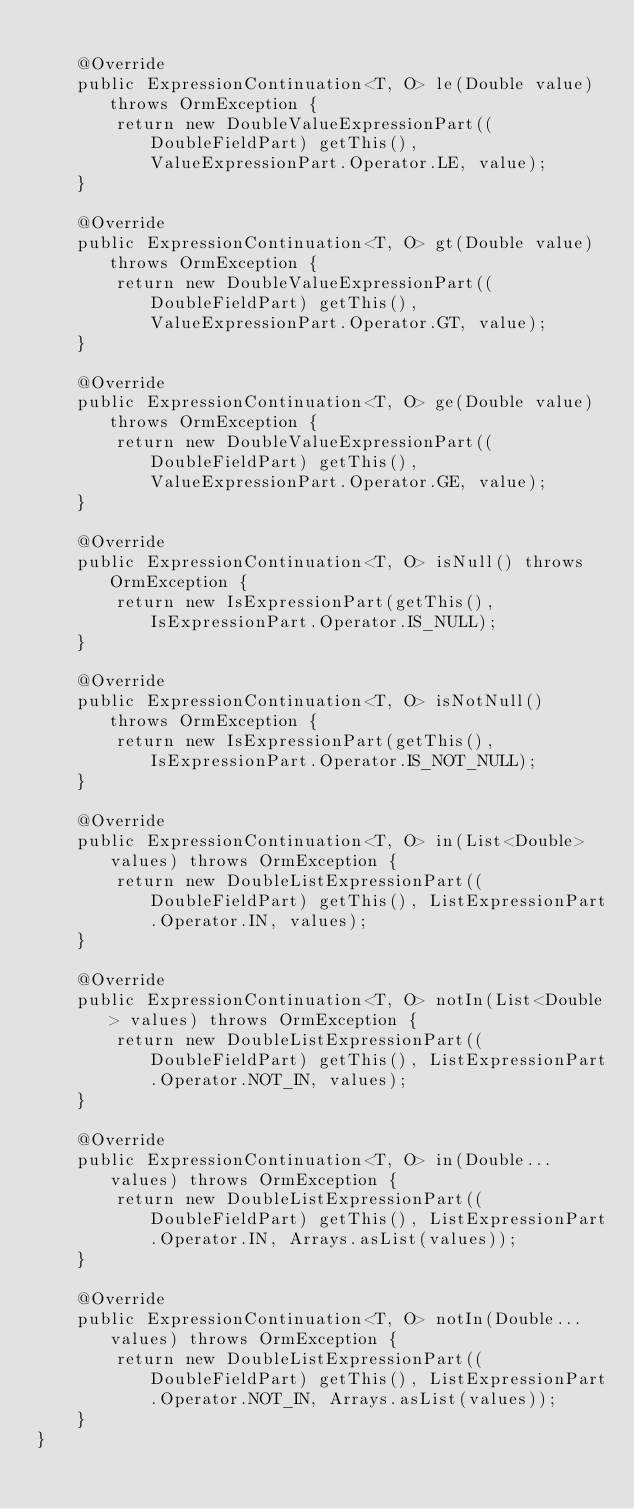<code> <loc_0><loc_0><loc_500><loc_500><_Java_>
    @Override
    public ExpressionContinuation<T, O> le(Double value) throws OrmException {
        return new DoubleValueExpressionPart((DoubleFieldPart) getThis(), ValueExpressionPart.Operator.LE, value);
    }

    @Override
    public ExpressionContinuation<T, O> gt(Double value) throws OrmException {
        return new DoubleValueExpressionPart((DoubleFieldPart) getThis(), ValueExpressionPart.Operator.GT, value);
    }

    @Override
    public ExpressionContinuation<T, O> ge(Double value) throws OrmException {
        return new DoubleValueExpressionPart((DoubleFieldPart) getThis(), ValueExpressionPart.Operator.GE, value);
    }

    @Override
    public ExpressionContinuation<T, O> isNull() throws OrmException {
        return new IsExpressionPart(getThis(), IsExpressionPart.Operator.IS_NULL);
    }

    @Override
    public ExpressionContinuation<T, O> isNotNull() throws OrmException {
        return new IsExpressionPart(getThis(), IsExpressionPart.Operator.IS_NOT_NULL);
    }

    @Override
    public ExpressionContinuation<T, O> in(List<Double> values) throws OrmException {
        return new DoubleListExpressionPart((DoubleFieldPart) getThis(), ListExpressionPart.Operator.IN, values);
    }

    @Override
    public ExpressionContinuation<T, O> notIn(List<Double> values) throws OrmException {
        return new DoubleListExpressionPart((DoubleFieldPart) getThis(), ListExpressionPart.Operator.NOT_IN, values);
    }

    @Override
    public ExpressionContinuation<T, O> in(Double... values) throws OrmException {
        return new DoubleListExpressionPart((DoubleFieldPart) getThis(), ListExpressionPart.Operator.IN, Arrays.asList(values));
    }

    @Override
    public ExpressionContinuation<T, O> notIn(Double... values) throws OrmException {
        return new DoubleListExpressionPart((DoubleFieldPart) getThis(), ListExpressionPart.Operator.NOT_IN, Arrays.asList(values));
    }
}
</code> 